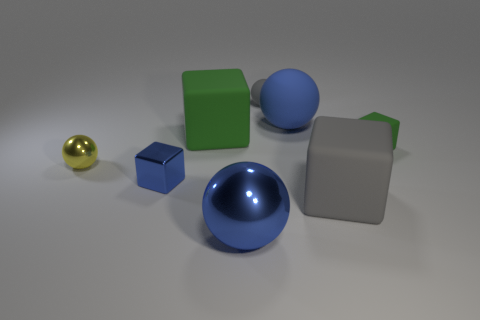Subtract 1 cubes. How many cubes are left? 3 Subtract all red blocks. Subtract all red cylinders. How many blocks are left? 4 Add 1 large rubber blocks. How many objects exist? 9 Add 1 blue matte things. How many blue matte things are left? 2 Add 4 tiny metal spheres. How many tiny metal spheres exist? 5 Subtract 0 red blocks. How many objects are left? 8 Subtract all big cubes. Subtract all big gray metal balls. How many objects are left? 6 